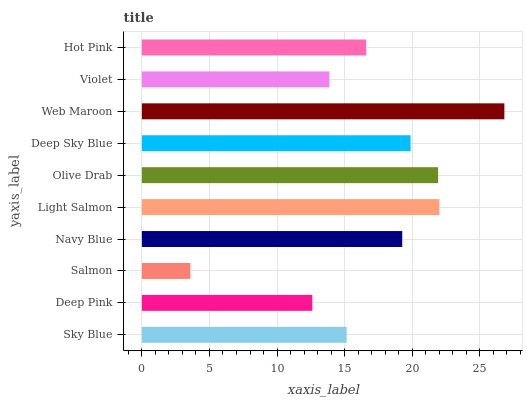Is Salmon the minimum?
Answer yes or no. Yes. Is Web Maroon the maximum?
Answer yes or no. Yes. Is Deep Pink the minimum?
Answer yes or no. No. Is Deep Pink the maximum?
Answer yes or no. No. Is Sky Blue greater than Deep Pink?
Answer yes or no. Yes. Is Deep Pink less than Sky Blue?
Answer yes or no. Yes. Is Deep Pink greater than Sky Blue?
Answer yes or no. No. Is Sky Blue less than Deep Pink?
Answer yes or no. No. Is Navy Blue the high median?
Answer yes or no. Yes. Is Hot Pink the low median?
Answer yes or no. Yes. Is Web Maroon the high median?
Answer yes or no. No. Is Olive Drab the low median?
Answer yes or no. No. 